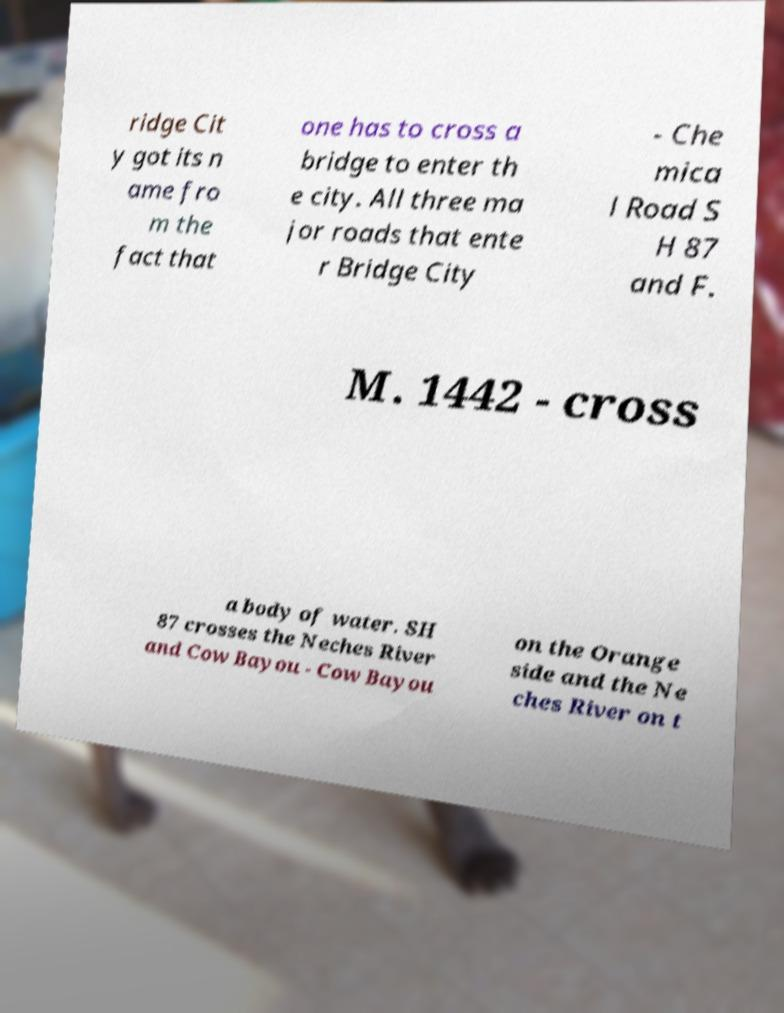Please read and relay the text visible in this image. What does it say? ridge Cit y got its n ame fro m the fact that one has to cross a bridge to enter th e city. All three ma jor roads that ente r Bridge City - Che mica l Road S H 87 and F. M. 1442 - cross a body of water. SH 87 crosses the Neches River and Cow Bayou - Cow Bayou on the Orange side and the Ne ches River on t 